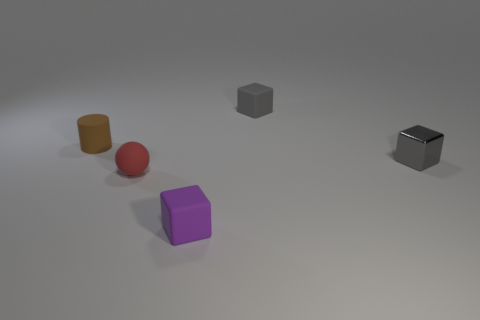How many objects are tiny brown cylinders or small matte objects that are right of the red thing?
Give a very brief answer. 3. The red object that is the same size as the purple object is what shape?
Keep it short and to the point. Sphere. How many small rubber cubes have the same color as the small metallic object?
Ensure brevity in your answer.  1. Does the small gray thing in front of the small brown matte object have the same material as the small red sphere?
Your response must be concise. No. The tiny shiny thing is what shape?
Make the answer very short. Cube. What number of blue objects are either tiny shiny spheres or small cylinders?
Offer a very short reply. 0. How many other things are made of the same material as the tiny brown cylinder?
Your response must be concise. 3. Do the small gray object to the right of the small gray matte thing and the tiny gray matte object have the same shape?
Your response must be concise. Yes. Is there a large purple object?
Ensure brevity in your answer.  No. Is there anything else that has the same shape as the brown thing?
Provide a succinct answer. No. 